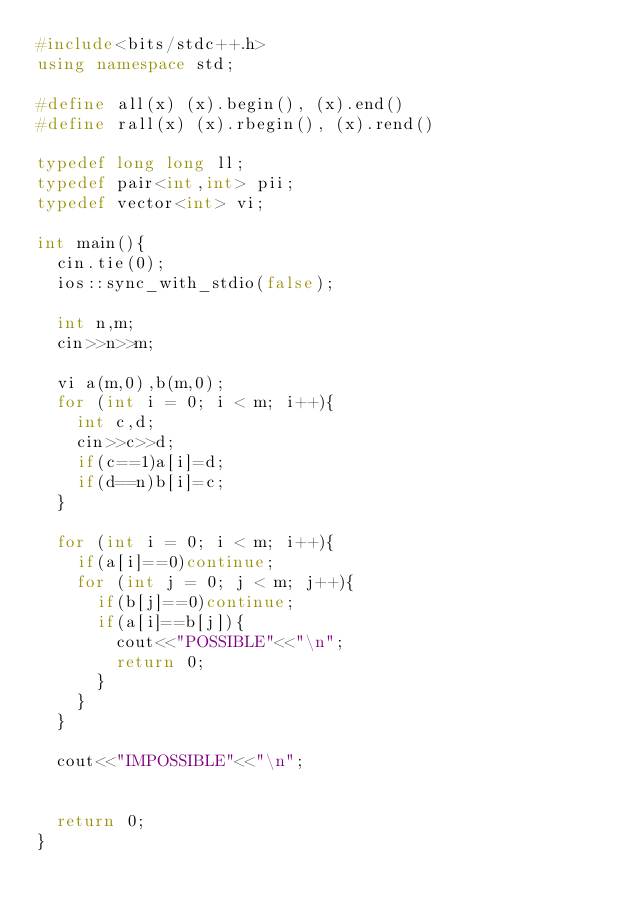Convert code to text. <code><loc_0><loc_0><loc_500><loc_500><_C++_>#include<bits/stdc++.h>
using namespace std;

#define all(x) (x).begin(), (x).end()
#define rall(x) (x).rbegin(), (x).rend()

typedef long long ll;
typedef pair<int,int> pii;
typedef vector<int> vi;

int main(){
	cin.tie(0);
	ios::sync_with_stdio(false);

	int n,m;
	cin>>n>>m;

	vi a(m,0),b(m,0);
	for (int i = 0; i < m; i++){
		int c,d;
		cin>>c>>d;
		if(c==1)a[i]=d;
		if(d==n)b[i]=c;
	}

	for (int i = 0; i < m; i++){
		if(a[i]==0)continue;
		for (int j = 0; j < m; j++){
			if(b[j]==0)continue;
			if(a[i]==b[j]){
				cout<<"POSSIBLE"<<"\n";
				return 0;
			}
		}
	}

	cout<<"IMPOSSIBLE"<<"\n";


	return 0;
}</code> 